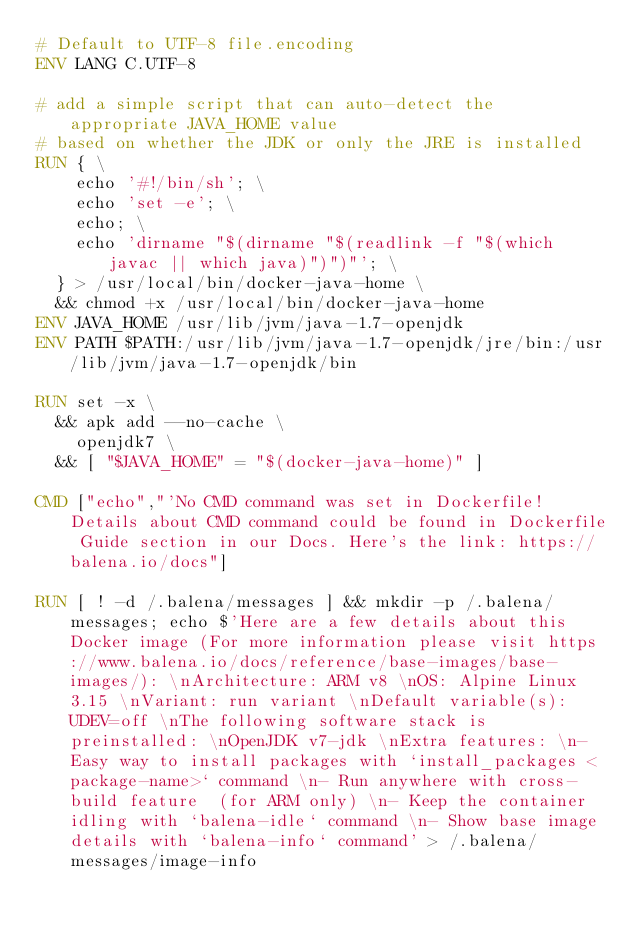Convert code to text. <code><loc_0><loc_0><loc_500><loc_500><_Dockerfile_># Default to UTF-8 file.encoding
ENV LANG C.UTF-8

# add a simple script that can auto-detect the appropriate JAVA_HOME value
# based on whether the JDK or only the JRE is installed
RUN { \
		echo '#!/bin/sh'; \
		echo 'set -e'; \
		echo; \
		echo 'dirname "$(dirname "$(readlink -f "$(which javac || which java)")")"'; \
	} > /usr/local/bin/docker-java-home \
	&& chmod +x /usr/local/bin/docker-java-home
ENV JAVA_HOME /usr/lib/jvm/java-1.7-openjdk
ENV PATH $PATH:/usr/lib/jvm/java-1.7-openjdk/jre/bin:/usr/lib/jvm/java-1.7-openjdk/bin

RUN set -x \
	&& apk add --no-cache \
		openjdk7 \
	&& [ "$JAVA_HOME" = "$(docker-java-home)" ]

CMD ["echo","'No CMD command was set in Dockerfile! Details about CMD command could be found in Dockerfile Guide section in our Docs. Here's the link: https://balena.io/docs"]

RUN [ ! -d /.balena/messages ] && mkdir -p /.balena/messages; echo $'Here are a few details about this Docker image (For more information please visit https://www.balena.io/docs/reference/base-images/base-images/): \nArchitecture: ARM v8 \nOS: Alpine Linux 3.15 \nVariant: run variant \nDefault variable(s): UDEV=off \nThe following software stack is preinstalled: \nOpenJDK v7-jdk \nExtra features: \n- Easy way to install packages with `install_packages <package-name>` command \n- Run anywhere with cross-build feature  (for ARM only) \n- Keep the container idling with `balena-idle` command \n- Show base image details with `balena-info` command' > /.balena/messages/image-info
</code> 